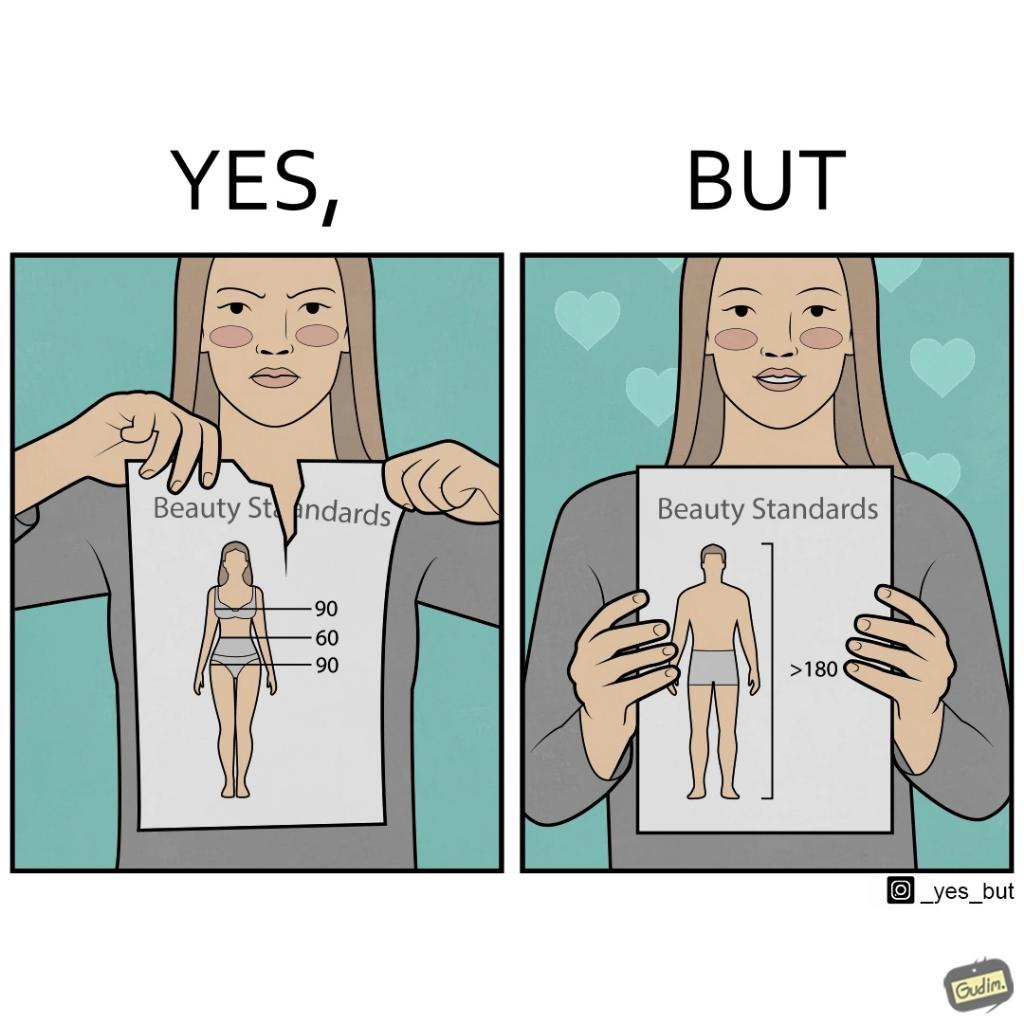What is shown in the left half versus the right half of this image? In the left part of the image: The image shows an angry woman tearing a piece of paper titled 'Beauty Standards' that shows the ideal measurements of various parts of a female's body to be called beautiful. In the right part of the image: The image shows a happy woman showing a piece of paper titled 'Beauty Standards' that shows that the ideal height of a male's body should be more than 180cm to be called beautiful. 